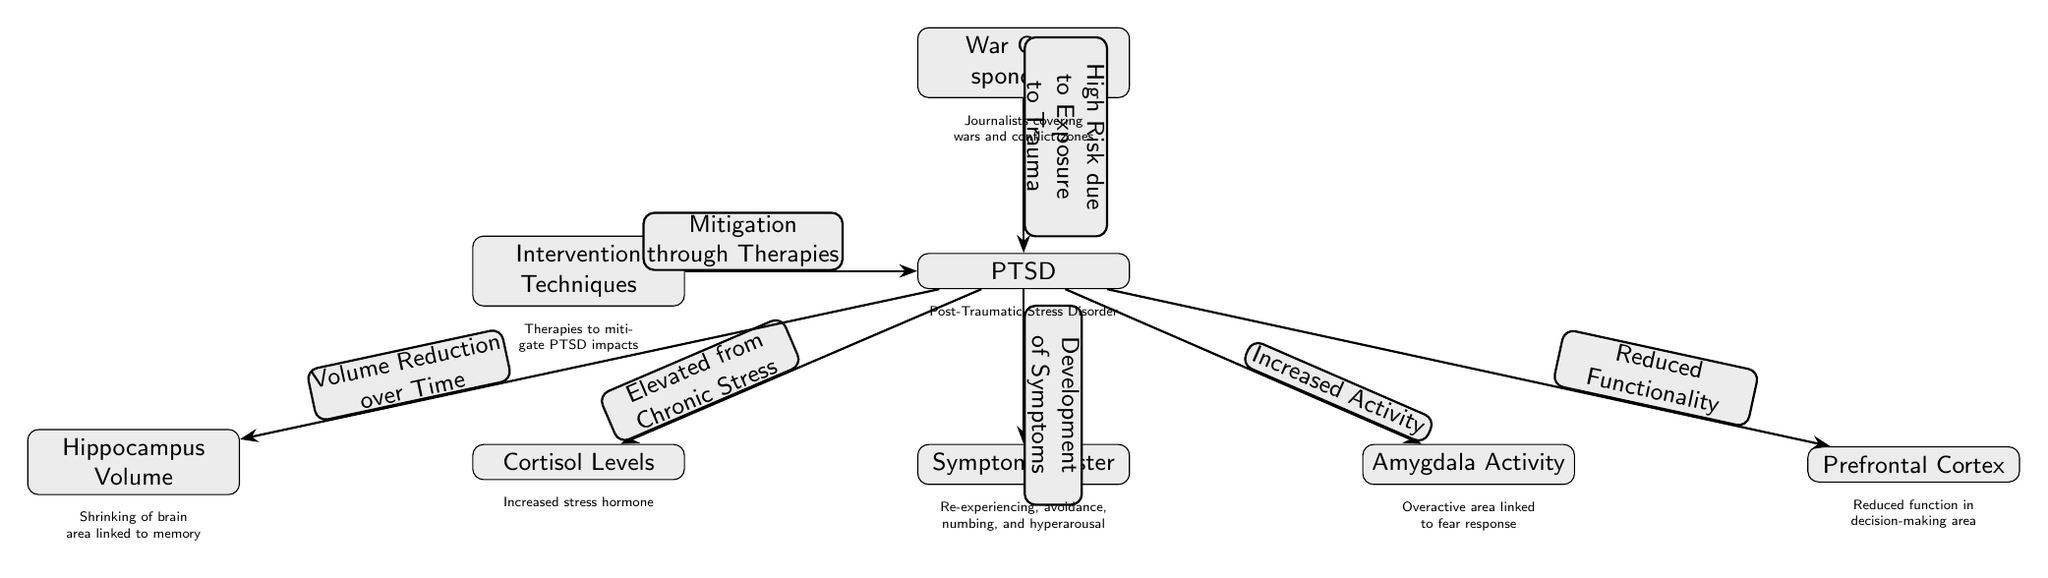What is PTSD in the context of this diagram? The diagram identifies PTSD as Post-Traumatic Stress Disorder, which is specifically connected to war correspondents due to their high exposure to trauma.
Answer: Post-Traumatic Stress Disorder How many nodes are there in the diagram? To determine the number of nodes, count the individual elements displayed. The nodes present are War Correspondents, PTSD, Cortisol Levels, Hippocampus Volume, Amygdala Activity, Prefrontal Cortex, Symptom Cluster, and Intervention Techniques, totaling eight nodes.
Answer: 8 What relationship is indicated between PTSD and Cortisol Levels? The diagram describes the relationship as "Elevated from Chronic Stress," meaning that PTSD leads to increased cortisol levels, a stress hormone.
Answer: Elevated from Chronic Stress What does the relationship between PTSD and the Amygdala indicate? The diagram shows that PTSD results in "Increased Activity" in the Amygdala, which relates to its role in the fear response.
Answer: Increased Activity What is the impact of PTSD on the Prefrontal Cortex according to the diagram? The diagram specifies that PTSD leads to "Reduced Functionality" in the Prefrontal Cortex, which suggests impairment in cognitive functions like decision-making.
Answer: Reduced Functionality How do Intervention Techniques relate to PTSD? The diagram indicates that Intervention Techniques are aimed at "Mitigation through Therapies," suggesting that various therapeutic approaches are employed to alleviate the effects of PTSD.
Answer: Mitigation through Therapies What is the symptom cluster associated with PTSD? The diagram lists symptoms associated with PTSD as "Re-experiencing, avoidance, numbing, and hyperarousal," which are common manifestations of the disorder.
Answer: Re-experiencing, avoidance, numbing, and hyperarousal How does the Hippocampus relate to PTSD over time? The diagram states that PTSD leads to a "Volume Reduction over Time" in the Hippocampus, which indicates a progressive decrease in this brain region associated with memory.
Answer: Volume Reduction over Time What is the primary cause of PTSD in war correspondents according to the diagram? The diagram notes "High Risk due to Exposure to Trauma" as the primary cause, highlighting the hazardous nature of their work in conflict zones.
Answer: High Risk due to Exposure to Trauma 